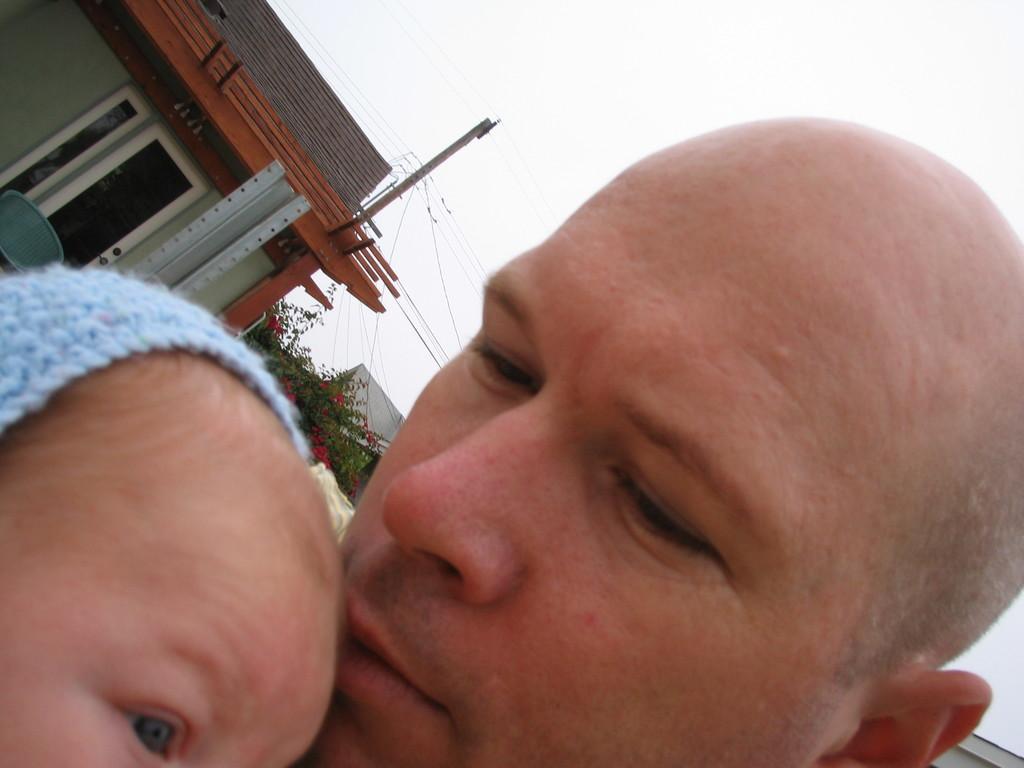How would you summarize this image in a sentence or two? In this Image I can see two person faces. Back I can see few buildings,door,current pole,wires and trees. The sky is in white color. 